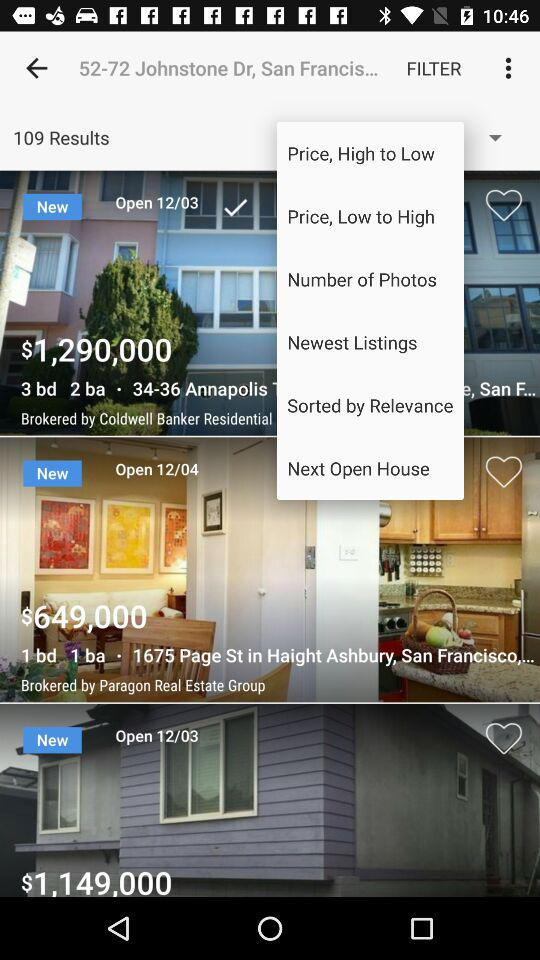What is the search location? The search location is "52-72 Johnstone Dr, San Francis...". 